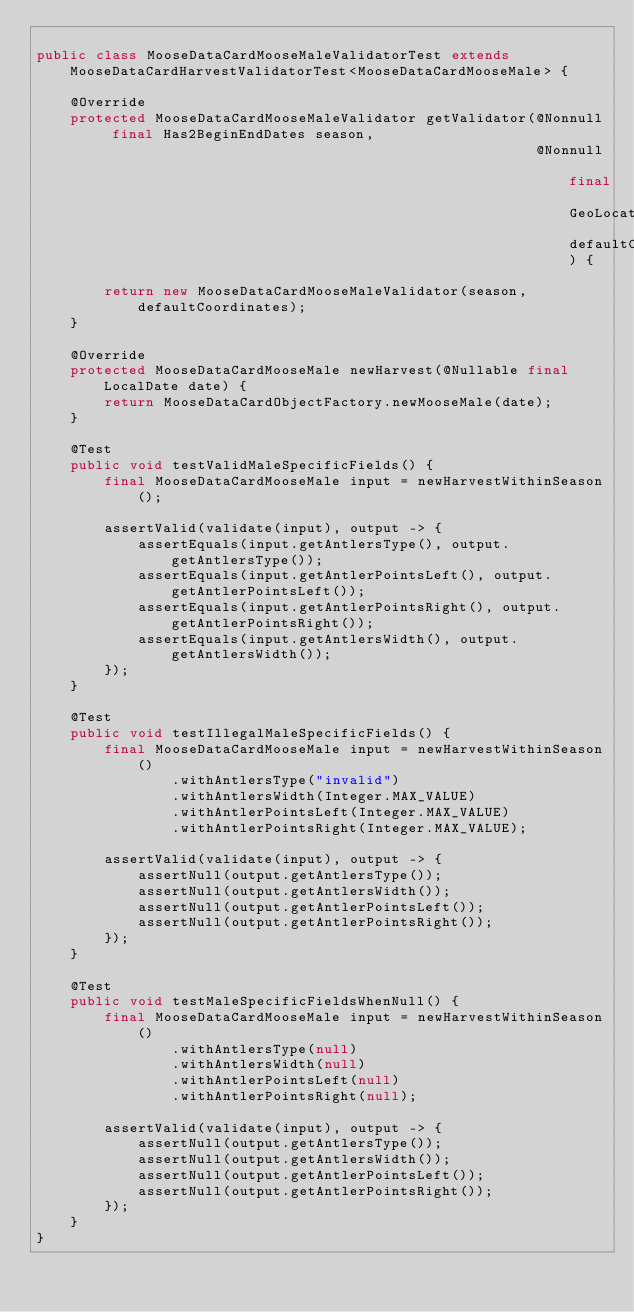Convert code to text. <code><loc_0><loc_0><loc_500><loc_500><_Java_>
public class MooseDataCardMooseMaleValidatorTest extends MooseDataCardHarvestValidatorTest<MooseDataCardMooseMale> {

    @Override
    protected MooseDataCardMooseMaleValidator getValidator(@Nonnull final Has2BeginEndDates season,
                                                           @Nonnull final GeoLocation defaultCoordinates) {

        return new MooseDataCardMooseMaleValidator(season, defaultCoordinates);
    }

    @Override
    protected MooseDataCardMooseMale newHarvest(@Nullable final LocalDate date) {
        return MooseDataCardObjectFactory.newMooseMale(date);
    }

    @Test
    public void testValidMaleSpecificFields() {
        final MooseDataCardMooseMale input = newHarvestWithinSeason();

        assertValid(validate(input), output -> {
            assertEquals(input.getAntlersType(), output.getAntlersType());
            assertEquals(input.getAntlerPointsLeft(), output.getAntlerPointsLeft());
            assertEquals(input.getAntlerPointsRight(), output.getAntlerPointsRight());
            assertEquals(input.getAntlersWidth(), output.getAntlersWidth());
        });
    }

    @Test
    public void testIllegalMaleSpecificFields() {
        final MooseDataCardMooseMale input = newHarvestWithinSeason()
                .withAntlersType("invalid")
                .withAntlersWidth(Integer.MAX_VALUE)
                .withAntlerPointsLeft(Integer.MAX_VALUE)
                .withAntlerPointsRight(Integer.MAX_VALUE);

        assertValid(validate(input), output -> {
            assertNull(output.getAntlersType());
            assertNull(output.getAntlersWidth());
            assertNull(output.getAntlerPointsLeft());
            assertNull(output.getAntlerPointsRight());
        });
    }

    @Test
    public void testMaleSpecificFieldsWhenNull() {
        final MooseDataCardMooseMale input = newHarvestWithinSeason()
                .withAntlersType(null)
                .withAntlersWidth(null)
                .withAntlerPointsLeft(null)
                .withAntlerPointsRight(null);

        assertValid(validate(input), output -> {
            assertNull(output.getAntlersType());
            assertNull(output.getAntlersWidth());
            assertNull(output.getAntlerPointsLeft());
            assertNull(output.getAntlerPointsRight());
        });
    }
}
</code> 